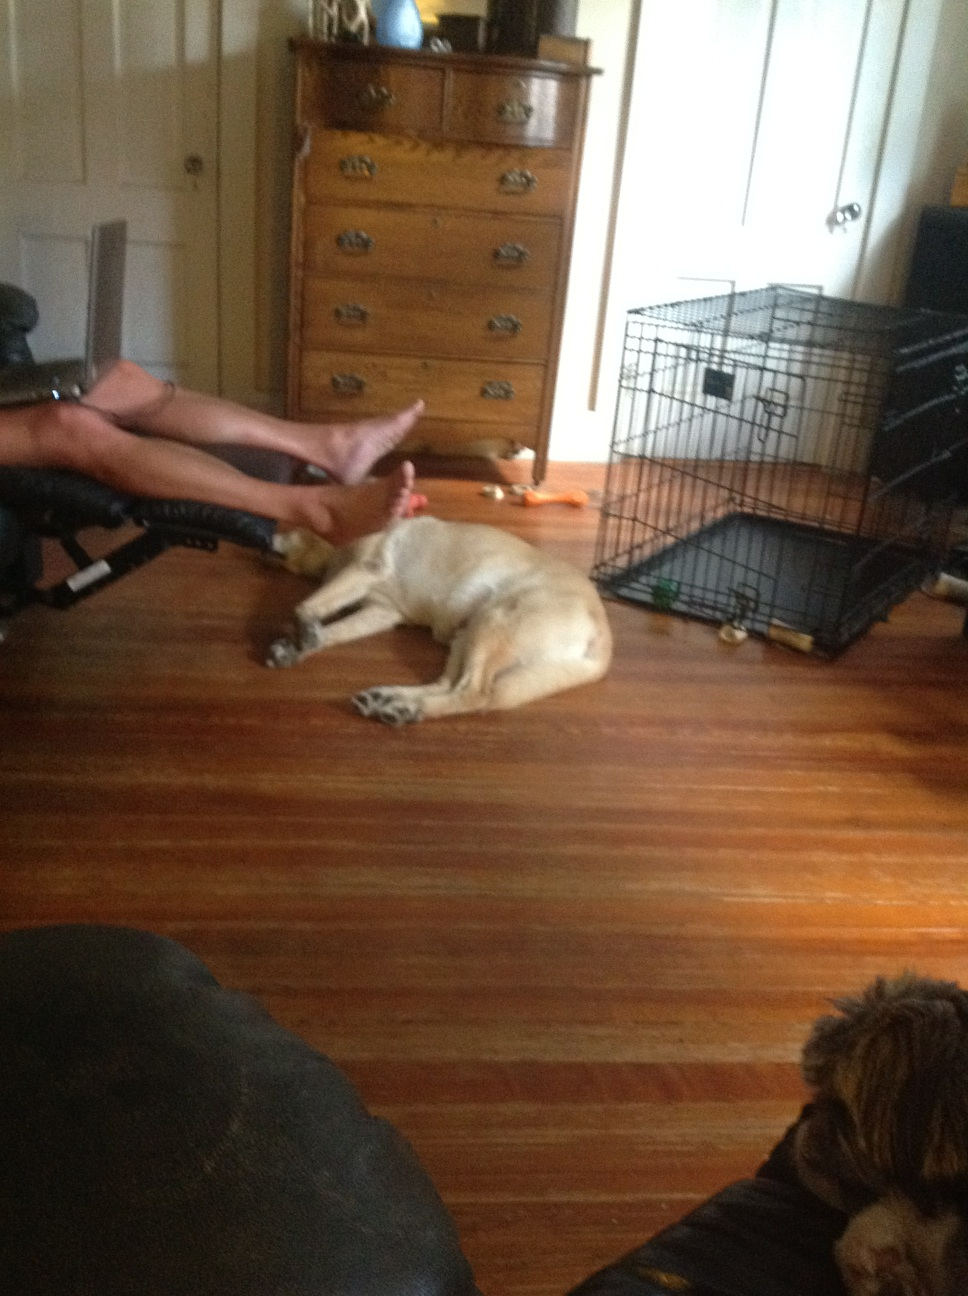What objects are visible near the pet crate? Next to the pet crate on the floor, there are a few objects that seem to be pet-related. I can see a bone-shaped toy, suitable for dogs to chew on, and what looks to be a small green ball. These toys suggest that the pets in the room are provided with means for entertainment and play. 